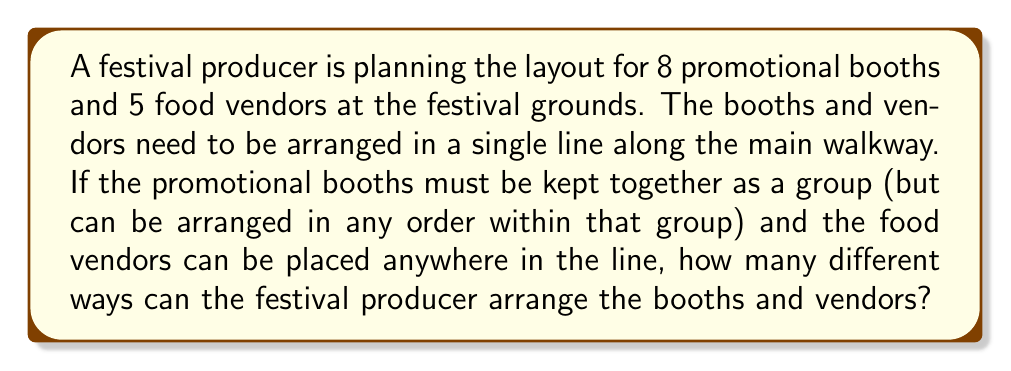Could you help me with this problem? Let's break this problem down into steps:

1) First, we need to consider the promotional booths as a single unit. This means we essentially have 6 elements to arrange: the group of promotional booths and the 5 individual food vendors.

2) The number of ways to arrange these 6 elements is a straightforward permutation:
   
   $$P(6,6) = 6! = 6 \times 5 \times 4 \times 3 \times 2 \times 1 = 720$$

3) However, we're not done yet. For each of these 720 arrangements, the 8 promotional booths within their group can be arranged in different ways. This is another permutation:

   $$P(8,8) = 8! = 40,320$$

4) By the multiplication principle, the total number of possible arrangements is the product of the number of ways to arrange the groups and the number of ways to arrange the booths within their group:

   $$720 \times 40,320 = 29,030,400$$

Therefore, there are 29,030,400 different ways to arrange the promotional booths and food vendors.
Answer: 29,030,400 